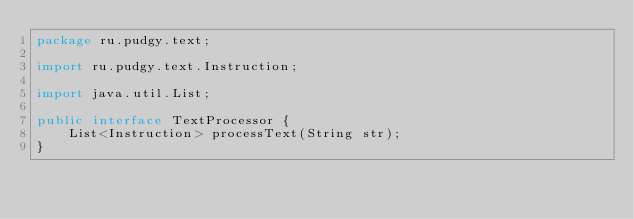Convert code to text. <code><loc_0><loc_0><loc_500><loc_500><_Java_>package ru.pudgy.text;

import ru.pudgy.text.Instruction;

import java.util.List;

public interface TextProcessor {
    List<Instruction> processText(String str);
}
</code> 